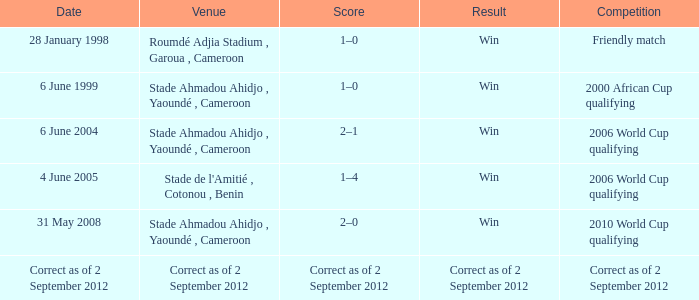What was the result for a friendly match? Win. 